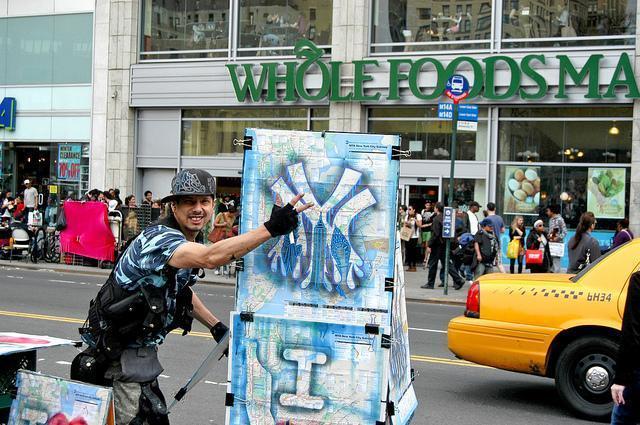How many bus routes stop here?
Give a very brief answer. 2. How many people are there?
Give a very brief answer. 2. How many skateboards are tipped up?
Give a very brief answer. 0. 